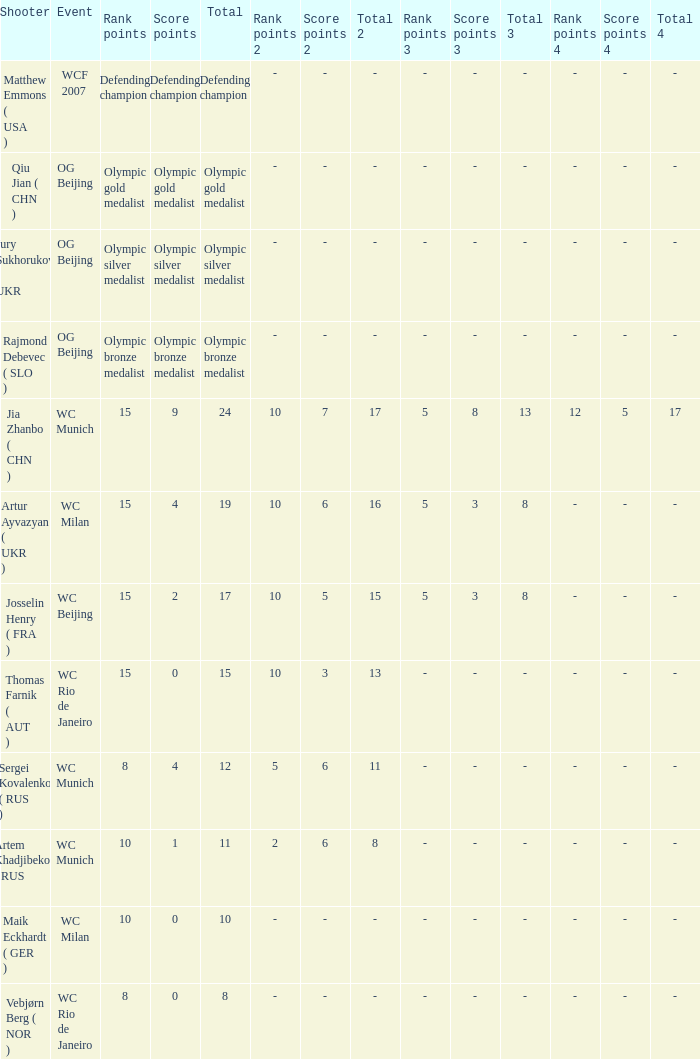With a total of 11, what is the score points? 1.0. 